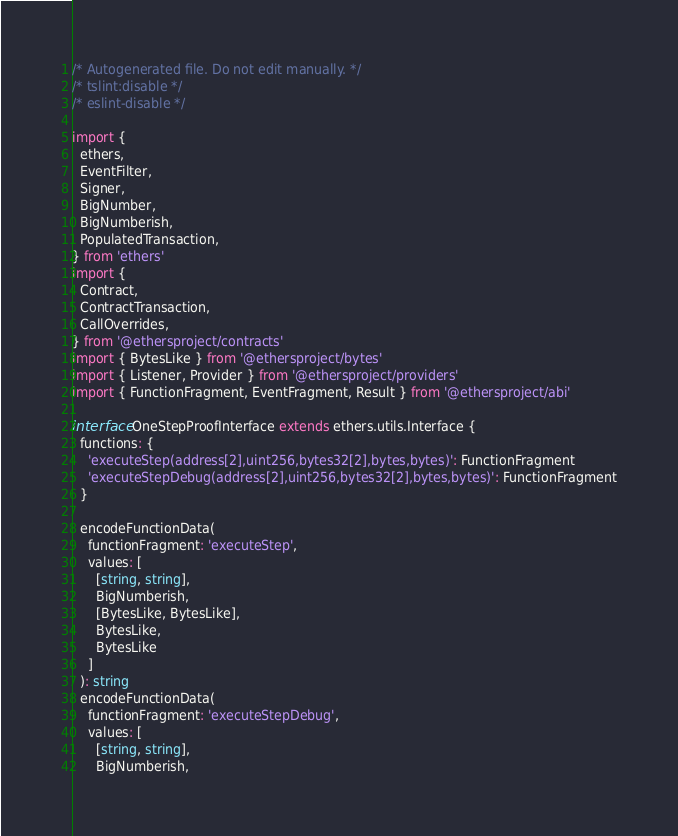<code> <loc_0><loc_0><loc_500><loc_500><_TypeScript_>/* Autogenerated file. Do not edit manually. */
/* tslint:disable */
/* eslint-disable */

import {
  ethers,
  EventFilter,
  Signer,
  BigNumber,
  BigNumberish,
  PopulatedTransaction,
} from 'ethers'
import {
  Contract,
  ContractTransaction,
  CallOverrides,
} from '@ethersproject/contracts'
import { BytesLike } from '@ethersproject/bytes'
import { Listener, Provider } from '@ethersproject/providers'
import { FunctionFragment, EventFragment, Result } from '@ethersproject/abi'

interface OneStepProofInterface extends ethers.utils.Interface {
  functions: {
    'executeStep(address[2],uint256,bytes32[2],bytes,bytes)': FunctionFragment
    'executeStepDebug(address[2],uint256,bytes32[2],bytes,bytes)': FunctionFragment
  }

  encodeFunctionData(
    functionFragment: 'executeStep',
    values: [
      [string, string],
      BigNumberish,
      [BytesLike, BytesLike],
      BytesLike,
      BytesLike
    ]
  ): string
  encodeFunctionData(
    functionFragment: 'executeStepDebug',
    values: [
      [string, string],
      BigNumberish,</code> 